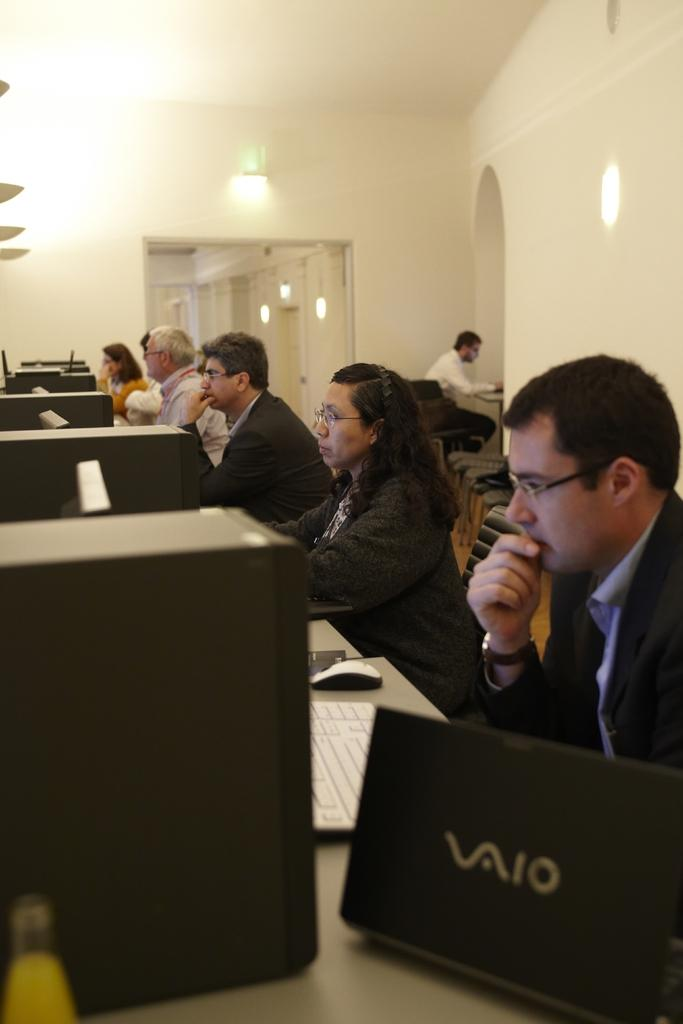What are the people in the image doing? The people are sitting in the image. Where are the people sitting in relation to the desk? The people are sitting in front of a desk. What is on the desk in the image? There are systems on the desk. What can be seen in the image that provides illumination? There are lights visible in the image. How many ladybugs can be seen crawling on the systems in the image? There are no ladybugs present in the image; it features people sitting in front of a desk with systems on it. What type of straw is being used to drink from the systems in the image? There is no straw visible in the image; it only shows people sitting in front of a desk with systems on it. 